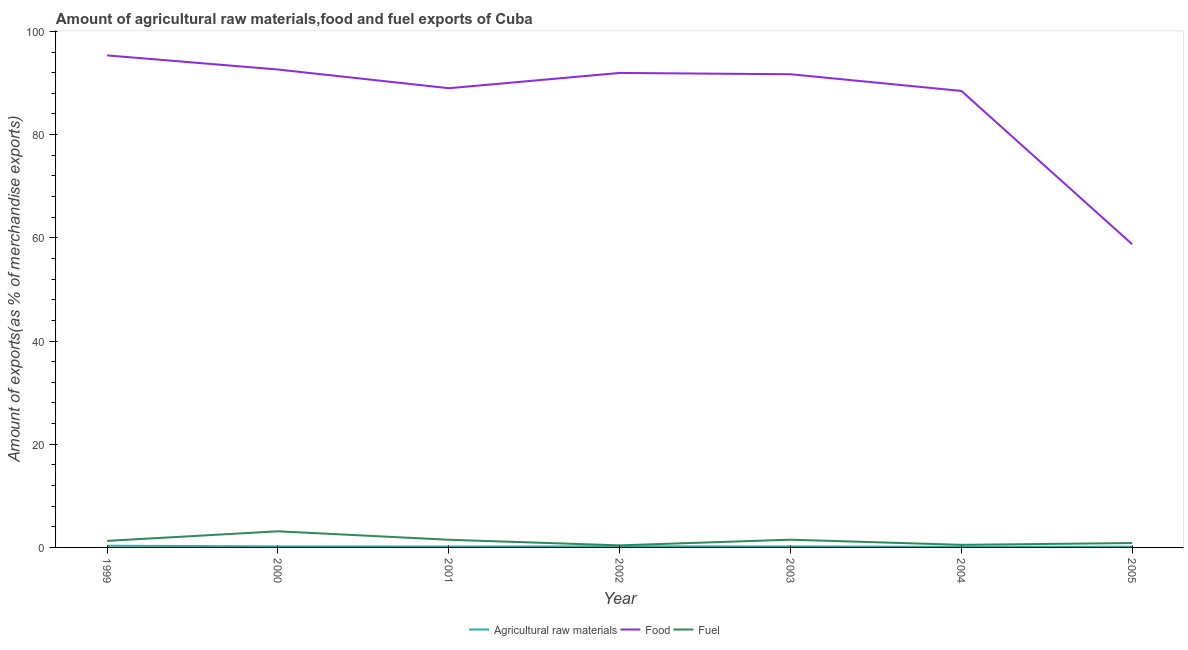How many different coloured lines are there?
Keep it short and to the point. 3. Does the line corresponding to percentage of raw materials exports intersect with the line corresponding to percentage of food exports?
Offer a very short reply. No. What is the percentage of fuel exports in 1999?
Make the answer very short. 1.27. Across all years, what is the maximum percentage of raw materials exports?
Offer a terse response. 0.32. Across all years, what is the minimum percentage of raw materials exports?
Provide a short and direct response. 0.12. In which year was the percentage of food exports maximum?
Make the answer very short. 1999. In which year was the percentage of food exports minimum?
Your response must be concise. 2005. What is the total percentage of raw materials exports in the graph?
Keep it short and to the point. 1.38. What is the difference between the percentage of raw materials exports in 2000 and that in 2001?
Your answer should be compact. 0.02. What is the difference between the percentage of fuel exports in 2001 and the percentage of food exports in 2002?
Your response must be concise. -90.47. What is the average percentage of food exports per year?
Your response must be concise. 86.83. In the year 2003, what is the difference between the percentage of raw materials exports and percentage of food exports?
Your answer should be compact. -91.51. In how many years, is the percentage of food exports greater than 88 %?
Your response must be concise. 6. What is the ratio of the percentage of food exports in 1999 to that in 2004?
Ensure brevity in your answer.  1.08. What is the difference between the highest and the second highest percentage of food exports?
Your answer should be very brief. 2.74. What is the difference between the highest and the lowest percentage of raw materials exports?
Your answer should be very brief. 0.2. In how many years, is the percentage of raw materials exports greater than the average percentage of raw materials exports taken over all years?
Your response must be concise. 3. Is it the case that in every year, the sum of the percentage of raw materials exports and percentage of food exports is greater than the percentage of fuel exports?
Offer a terse response. Yes. Does the percentage of food exports monotonically increase over the years?
Make the answer very short. No. How many lines are there?
Make the answer very short. 3. What is the difference between two consecutive major ticks on the Y-axis?
Give a very brief answer. 20. Are the values on the major ticks of Y-axis written in scientific E-notation?
Ensure brevity in your answer.  No. Does the graph contain grids?
Give a very brief answer. No. How many legend labels are there?
Your answer should be compact. 3. How are the legend labels stacked?
Your response must be concise. Horizontal. What is the title of the graph?
Provide a succinct answer. Amount of agricultural raw materials,food and fuel exports of Cuba. Does "Industry" appear as one of the legend labels in the graph?
Your response must be concise. No. What is the label or title of the Y-axis?
Give a very brief answer. Amount of exports(as % of merchandise exports). What is the Amount of exports(as % of merchandise exports) in Agricultural raw materials in 1999?
Your answer should be very brief. 0.32. What is the Amount of exports(as % of merchandise exports) of Food in 1999?
Your answer should be compact. 95.35. What is the Amount of exports(as % of merchandise exports) in Fuel in 1999?
Offer a terse response. 1.27. What is the Amount of exports(as % of merchandise exports) of Agricultural raw materials in 2000?
Your response must be concise. 0.2. What is the Amount of exports(as % of merchandise exports) of Food in 2000?
Make the answer very short. 92.62. What is the Amount of exports(as % of merchandise exports) of Fuel in 2000?
Your answer should be very brief. 3.13. What is the Amount of exports(as % of merchandise exports) of Agricultural raw materials in 2001?
Make the answer very short. 0.18. What is the Amount of exports(as % of merchandise exports) in Food in 2001?
Offer a terse response. 88.99. What is the Amount of exports(as % of merchandise exports) of Fuel in 2001?
Provide a short and direct response. 1.49. What is the Amount of exports(as % of merchandise exports) of Agricultural raw materials in 2002?
Provide a succinct answer. 0.21. What is the Amount of exports(as % of merchandise exports) in Food in 2002?
Your answer should be compact. 91.95. What is the Amount of exports(as % of merchandise exports) of Fuel in 2002?
Make the answer very short. 0.4. What is the Amount of exports(as % of merchandise exports) in Agricultural raw materials in 2003?
Offer a very short reply. 0.2. What is the Amount of exports(as % of merchandise exports) of Food in 2003?
Your answer should be very brief. 91.7. What is the Amount of exports(as % of merchandise exports) in Fuel in 2003?
Your response must be concise. 1.5. What is the Amount of exports(as % of merchandise exports) of Agricultural raw materials in 2004?
Give a very brief answer. 0.12. What is the Amount of exports(as % of merchandise exports) in Food in 2004?
Offer a very short reply. 88.46. What is the Amount of exports(as % of merchandise exports) of Fuel in 2004?
Provide a succinct answer. 0.5. What is the Amount of exports(as % of merchandise exports) of Agricultural raw materials in 2005?
Provide a short and direct response. 0.14. What is the Amount of exports(as % of merchandise exports) in Food in 2005?
Keep it short and to the point. 58.74. What is the Amount of exports(as % of merchandise exports) in Fuel in 2005?
Your answer should be very brief. 0.85. Across all years, what is the maximum Amount of exports(as % of merchandise exports) of Agricultural raw materials?
Your answer should be very brief. 0.32. Across all years, what is the maximum Amount of exports(as % of merchandise exports) of Food?
Keep it short and to the point. 95.35. Across all years, what is the maximum Amount of exports(as % of merchandise exports) of Fuel?
Your answer should be very brief. 3.13. Across all years, what is the minimum Amount of exports(as % of merchandise exports) in Agricultural raw materials?
Provide a succinct answer. 0.12. Across all years, what is the minimum Amount of exports(as % of merchandise exports) in Food?
Ensure brevity in your answer.  58.74. Across all years, what is the minimum Amount of exports(as % of merchandise exports) in Fuel?
Your answer should be compact. 0.4. What is the total Amount of exports(as % of merchandise exports) of Agricultural raw materials in the graph?
Ensure brevity in your answer.  1.38. What is the total Amount of exports(as % of merchandise exports) in Food in the graph?
Your answer should be very brief. 607.83. What is the total Amount of exports(as % of merchandise exports) of Fuel in the graph?
Your answer should be compact. 9.13. What is the difference between the Amount of exports(as % of merchandise exports) in Agricultural raw materials in 1999 and that in 2000?
Provide a short and direct response. 0.12. What is the difference between the Amount of exports(as % of merchandise exports) of Food in 1999 and that in 2000?
Your answer should be compact. 2.74. What is the difference between the Amount of exports(as % of merchandise exports) in Fuel in 1999 and that in 2000?
Offer a terse response. -1.86. What is the difference between the Amount of exports(as % of merchandise exports) in Agricultural raw materials in 1999 and that in 2001?
Your answer should be very brief. 0.15. What is the difference between the Amount of exports(as % of merchandise exports) in Food in 1999 and that in 2001?
Provide a succinct answer. 6.36. What is the difference between the Amount of exports(as % of merchandise exports) in Fuel in 1999 and that in 2001?
Offer a terse response. -0.22. What is the difference between the Amount of exports(as % of merchandise exports) of Agricultural raw materials in 1999 and that in 2002?
Offer a very short reply. 0.11. What is the difference between the Amount of exports(as % of merchandise exports) in Food in 1999 and that in 2002?
Ensure brevity in your answer.  3.4. What is the difference between the Amount of exports(as % of merchandise exports) of Fuel in 1999 and that in 2002?
Keep it short and to the point. 0.87. What is the difference between the Amount of exports(as % of merchandise exports) in Agricultural raw materials in 1999 and that in 2003?
Ensure brevity in your answer.  0.13. What is the difference between the Amount of exports(as % of merchandise exports) in Food in 1999 and that in 2003?
Make the answer very short. 3.65. What is the difference between the Amount of exports(as % of merchandise exports) of Fuel in 1999 and that in 2003?
Ensure brevity in your answer.  -0.23. What is the difference between the Amount of exports(as % of merchandise exports) in Agricultural raw materials in 1999 and that in 2004?
Your answer should be compact. 0.2. What is the difference between the Amount of exports(as % of merchandise exports) in Food in 1999 and that in 2004?
Make the answer very short. 6.89. What is the difference between the Amount of exports(as % of merchandise exports) in Fuel in 1999 and that in 2004?
Keep it short and to the point. 0.77. What is the difference between the Amount of exports(as % of merchandise exports) of Agricultural raw materials in 1999 and that in 2005?
Offer a very short reply. 0.18. What is the difference between the Amount of exports(as % of merchandise exports) in Food in 1999 and that in 2005?
Provide a succinct answer. 36.61. What is the difference between the Amount of exports(as % of merchandise exports) in Fuel in 1999 and that in 2005?
Give a very brief answer. 0.42. What is the difference between the Amount of exports(as % of merchandise exports) in Agricultural raw materials in 2000 and that in 2001?
Provide a short and direct response. 0.02. What is the difference between the Amount of exports(as % of merchandise exports) of Food in 2000 and that in 2001?
Your response must be concise. 3.62. What is the difference between the Amount of exports(as % of merchandise exports) of Fuel in 2000 and that in 2001?
Provide a succinct answer. 1.64. What is the difference between the Amount of exports(as % of merchandise exports) in Agricultural raw materials in 2000 and that in 2002?
Ensure brevity in your answer.  -0.01. What is the difference between the Amount of exports(as % of merchandise exports) in Food in 2000 and that in 2002?
Keep it short and to the point. 0.66. What is the difference between the Amount of exports(as % of merchandise exports) of Fuel in 2000 and that in 2002?
Provide a succinct answer. 2.72. What is the difference between the Amount of exports(as % of merchandise exports) in Agricultural raw materials in 2000 and that in 2003?
Your answer should be very brief. 0. What is the difference between the Amount of exports(as % of merchandise exports) of Food in 2000 and that in 2003?
Offer a terse response. 0.91. What is the difference between the Amount of exports(as % of merchandise exports) of Fuel in 2000 and that in 2003?
Your response must be concise. 1.63. What is the difference between the Amount of exports(as % of merchandise exports) in Agricultural raw materials in 2000 and that in 2004?
Provide a short and direct response. 0.08. What is the difference between the Amount of exports(as % of merchandise exports) in Food in 2000 and that in 2004?
Give a very brief answer. 4.15. What is the difference between the Amount of exports(as % of merchandise exports) in Fuel in 2000 and that in 2004?
Provide a short and direct response. 2.63. What is the difference between the Amount of exports(as % of merchandise exports) of Agricultural raw materials in 2000 and that in 2005?
Keep it short and to the point. 0.06. What is the difference between the Amount of exports(as % of merchandise exports) in Food in 2000 and that in 2005?
Offer a terse response. 33.87. What is the difference between the Amount of exports(as % of merchandise exports) in Fuel in 2000 and that in 2005?
Your response must be concise. 2.28. What is the difference between the Amount of exports(as % of merchandise exports) of Agricultural raw materials in 2001 and that in 2002?
Your answer should be compact. -0.04. What is the difference between the Amount of exports(as % of merchandise exports) in Food in 2001 and that in 2002?
Provide a succinct answer. -2.96. What is the difference between the Amount of exports(as % of merchandise exports) of Fuel in 2001 and that in 2002?
Your response must be concise. 1.08. What is the difference between the Amount of exports(as % of merchandise exports) of Agricultural raw materials in 2001 and that in 2003?
Your answer should be very brief. -0.02. What is the difference between the Amount of exports(as % of merchandise exports) of Food in 2001 and that in 2003?
Provide a short and direct response. -2.71. What is the difference between the Amount of exports(as % of merchandise exports) of Fuel in 2001 and that in 2003?
Keep it short and to the point. -0.01. What is the difference between the Amount of exports(as % of merchandise exports) in Agricultural raw materials in 2001 and that in 2004?
Your response must be concise. 0.05. What is the difference between the Amount of exports(as % of merchandise exports) in Food in 2001 and that in 2004?
Give a very brief answer. 0.53. What is the difference between the Amount of exports(as % of merchandise exports) of Fuel in 2001 and that in 2004?
Offer a very short reply. 0.99. What is the difference between the Amount of exports(as % of merchandise exports) of Agricultural raw materials in 2001 and that in 2005?
Make the answer very short. 0.03. What is the difference between the Amount of exports(as % of merchandise exports) of Food in 2001 and that in 2005?
Provide a succinct answer. 30.25. What is the difference between the Amount of exports(as % of merchandise exports) of Fuel in 2001 and that in 2005?
Provide a succinct answer. 0.64. What is the difference between the Amount of exports(as % of merchandise exports) of Agricultural raw materials in 2002 and that in 2003?
Your answer should be compact. 0.02. What is the difference between the Amount of exports(as % of merchandise exports) of Food in 2002 and that in 2003?
Give a very brief answer. 0.25. What is the difference between the Amount of exports(as % of merchandise exports) of Fuel in 2002 and that in 2003?
Provide a succinct answer. -1.1. What is the difference between the Amount of exports(as % of merchandise exports) of Agricultural raw materials in 2002 and that in 2004?
Ensure brevity in your answer.  0.09. What is the difference between the Amount of exports(as % of merchandise exports) of Food in 2002 and that in 2004?
Ensure brevity in your answer.  3.49. What is the difference between the Amount of exports(as % of merchandise exports) in Fuel in 2002 and that in 2004?
Provide a short and direct response. -0.1. What is the difference between the Amount of exports(as % of merchandise exports) in Agricultural raw materials in 2002 and that in 2005?
Make the answer very short. 0.07. What is the difference between the Amount of exports(as % of merchandise exports) in Food in 2002 and that in 2005?
Offer a terse response. 33.21. What is the difference between the Amount of exports(as % of merchandise exports) of Fuel in 2002 and that in 2005?
Keep it short and to the point. -0.45. What is the difference between the Amount of exports(as % of merchandise exports) in Agricultural raw materials in 2003 and that in 2004?
Make the answer very short. 0.07. What is the difference between the Amount of exports(as % of merchandise exports) of Food in 2003 and that in 2004?
Your answer should be compact. 3.24. What is the difference between the Amount of exports(as % of merchandise exports) of Fuel in 2003 and that in 2004?
Ensure brevity in your answer.  1. What is the difference between the Amount of exports(as % of merchandise exports) in Agricultural raw materials in 2003 and that in 2005?
Your answer should be compact. 0.05. What is the difference between the Amount of exports(as % of merchandise exports) of Food in 2003 and that in 2005?
Give a very brief answer. 32.96. What is the difference between the Amount of exports(as % of merchandise exports) of Fuel in 2003 and that in 2005?
Your response must be concise. 0.65. What is the difference between the Amount of exports(as % of merchandise exports) of Agricultural raw materials in 2004 and that in 2005?
Your answer should be very brief. -0.02. What is the difference between the Amount of exports(as % of merchandise exports) of Food in 2004 and that in 2005?
Offer a very short reply. 29.72. What is the difference between the Amount of exports(as % of merchandise exports) of Fuel in 2004 and that in 2005?
Offer a very short reply. -0.35. What is the difference between the Amount of exports(as % of merchandise exports) in Agricultural raw materials in 1999 and the Amount of exports(as % of merchandise exports) in Food in 2000?
Your answer should be compact. -92.29. What is the difference between the Amount of exports(as % of merchandise exports) in Agricultural raw materials in 1999 and the Amount of exports(as % of merchandise exports) in Fuel in 2000?
Give a very brief answer. -2.8. What is the difference between the Amount of exports(as % of merchandise exports) of Food in 1999 and the Amount of exports(as % of merchandise exports) of Fuel in 2000?
Your answer should be compact. 92.23. What is the difference between the Amount of exports(as % of merchandise exports) of Agricultural raw materials in 1999 and the Amount of exports(as % of merchandise exports) of Food in 2001?
Ensure brevity in your answer.  -88.67. What is the difference between the Amount of exports(as % of merchandise exports) in Agricultural raw materials in 1999 and the Amount of exports(as % of merchandise exports) in Fuel in 2001?
Offer a very short reply. -1.16. What is the difference between the Amount of exports(as % of merchandise exports) of Food in 1999 and the Amount of exports(as % of merchandise exports) of Fuel in 2001?
Offer a terse response. 93.87. What is the difference between the Amount of exports(as % of merchandise exports) in Agricultural raw materials in 1999 and the Amount of exports(as % of merchandise exports) in Food in 2002?
Offer a very short reply. -91.63. What is the difference between the Amount of exports(as % of merchandise exports) of Agricultural raw materials in 1999 and the Amount of exports(as % of merchandise exports) of Fuel in 2002?
Ensure brevity in your answer.  -0.08. What is the difference between the Amount of exports(as % of merchandise exports) of Food in 1999 and the Amount of exports(as % of merchandise exports) of Fuel in 2002?
Ensure brevity in your answer.  94.95. What is the difference between the Amount of exports(as % of merchandise exports) of Agricultural raw materials in 1999 and the Amount of exports(as % of merchandise exports) of Food in 2003?
Offer a very short reply. -91.38. What is the difference between the Amount of exports(as % of merchandise exports) of Agricultural raw materials in 1999 and the Amount of exports(as % of merchandise exports) of Fuel in 2003?
Make the answer very short. -1.18. What is the difference between the Amount of exports(as % of merchandise exports) of Food in 1999 and the Amount of exports(as % of merchandise exports) of Fuel in 2003?
Give a very brief answer. 93.85. What is the difference between the Amount of exports(as % of merchandise exports) of Agricultural raw materials in 1999 and the Amount of exports(as % of merchandise exports) of Food in 2004?
Your answer should be very brief. -88.14. What is the difference between the Amount of exports(as % of merchandise exports) of Agricultural raw materials in 1999 and the Amount of exports(as % of merchandise exports) of Fuel in 2004?
Your response must be concise. -0.18. What is the difference between the Amount of exports(as % of merchandise exports) in Food in 1999 and the Amount of exports(as % of merchandise exports) in Fuel in 2004?
Offer a very short reply. 94.85. What is the difference between the Amount of exports(as % of merchandise exports) of Agricultural raw materials in 1999 and the Amount of exports(as % of merchandise exports) of Food in 2005?
Your answer should be very brief. -58.42. What is the difference between the Amount of exports(as % of merchandise exports) in Agricultural raw materials in 1999 and the Amount of exports(as % of merchandise exports) in Fuel in 2005?
Provide a short and direct response. -0.53. What is the difference between the Amount of exports(as % of merchandise exports) of Food in 1999 and the Amount of exports(as % of merchandise exports) of Fuel in 2005?
Offer a very short reply. 94.5. What is the difference between the Amount of exports(as % of merchandise exports) in Agricultural raw materials in 2000 and the Amount of exports(as % of merchandise exports) in Food in 2001?
Ensure brevity in your answer.  -88.79. What is the difference between the Amount of exports(as % of merchandise exports) in Agricultural raw materials in 2000 and the Amount of exports(as % of merchandise exports) in Fuel in 2001?
Ensure brevity in your answer.  -1.29. What is the difference between the Amount of exports(as % of merchandise exports) in Food in 2000 and the Amount of exports(as % of merchandise exports) in Fuel in 2001?
Provide a short and direct response. 91.13. What is the difference between the Amount of exports(as % of merchandise exports) of Agricultural raw materials in 2000 and the Amount of exports(as % of merchandise exports) of Food in 2002?
Give a very brief answer. -91.75. What is the difference between the Amount of exports(as % of merchandise exports) in Agricultural raw materials in 2000 and the Amount of exports(as % of merchandise exports) in Fuel in 2002?
Your answer should be very brief. -0.2. What is the difference between the Amount of exports(as % of merchandise exports) of Food in 2000 and the Amount of exports(as % of merchandise exports) of Fuel in 2002?
Give a very brief answer. 92.21. What is the difference between the Amount of exports(as % of merchandise exports) in Agricultural raw materials in 2000 and the Amount of exports(as % of merchandise exports) in Food in 2003?
Give a very brief answer. -91.5. What is the difference between the Amount of exports(as % of merchandise exports) in Agricultural raw materials in 2000 and the Amount of exports(as % of merchandise exports) in Fuel in 2003?
Offer a terse response. -1.3. What is the difference between the Amount of exports(as % of merchandise exports) of Food in 2000 and the Amount of exports(as % of merchandise exports) of Fuel in 2003?
Offer a very short reply. 91.12. What is the difference between the Amount of exports(as % of merchandise exports) in Agricultural raw materials in 2000 and the Amount of exports(as % of merchandise exports) in Food in 2004?
Keep it short and to the point. -88.26. What is the difference between the Amount of exports(as % of merchandise exports) of Agricultural raw materials in 2000 and the Amount of exports(as % of merchandise exports) of Fuel in 2004?
Your answer should be compact. -0.3. What is the difference between the Amount of exports(as % of merchandise exports) in Food in 2000 and the Amount of exports(as % of merchandise exports) in Fuel in 2004?
Keep it short and to the point. 92.12. What is the difference between the Amount of exports(as % of merchandise exports) of Agricultural raw materials in 2000 and the Amount of exports(as % of merchandise exports) of Food in 2005?
Provide a succinct answer. -58.54. What is the difference between the Amount of exports(as % of merchandise exports) in Agricultural raw materials in 2000 and the Amount of exports(as % of merchandise exports) in Fuel in 2005?
Keep it short and to the point. -0.65. What is the difference between the Amount of exports(as % of merchandise exports) in Food in 2000 and the Amount of exports(as % of merchandise exports) in Fuel in 2005?
Give a very brief answer. 91.77. What is the difference between the Amount of exports(as % of merchandise exports) in Agricultural raw materials in 2001 and the Amount of exports(as % of merchandise exports) in Food in 2002?
Provide a short and direct response. -91.78. What is the difference between the Amount of exports(as % of merchandise exports) in Agricultural raw materials in 2001 and the Amount of exports(as % of merchandise exports) in Fuel in 2002?
Make the answer very short. -0.23. What is the difference between the Amount of exports(as % of merchandise exports) of Food in 2001 and the Amount of exports(as % of merchandise exports) of Fuel in 2002?
Give a very brief answer. 88.59. What is the difference between the Amount of exports(as % of merchandise exports) in Agricultural raw materials in 2001 and the Amount of exports(as % of merchandise exports) in Food in 2003?
Your response must be concise. -91.53. What is the difference between the Amount of exports(as % of merchandise exports) in Agricultural raw materials in 2001 and the Amount of exports(as % of merchandise exports) in Fuel in 2003?
Ensure brevity in your answer.  -1.32. What is the difference between the Amount of exports(as % of merchandise exports) of Food in 2001 and the Amount of exports(as % of merchandise exports) of Fuel in 2003?
Your answer should be very brief. 87.49. What is the difference between the Amount of exports(as % of merchandise exports) of Agricultural raw materials in 2001 and the Amount of exports(as % of merchandise exports) of Food in 2004?
Your answer should be very brief. -88.29. What is the difference between the Amount of exports(as % of merchandise exports) in Agricultural raw materials in 2001 and the Amount of exports(as % of merchandise exports) in Fuel in 2004?
Make the answer very short. -0.32. What is the difference between the Amount of exports(as % of merchandise exports) of Food in 2001 and the Amount of exports(as % of merchandise exports) of Fuel in 2004?
Provide a succinct answer. 88.49. What is the difference between the Amount of exports(as % of merchandise exports) of Agricultural raw materials in 2001 and the Amount of exports(as % of merchandise exports) of Food in 2005?
Your answer should be very brief. -58.57. What is the difference between the Amount of exports(as % of merchandise exports) of Agricultural raw materials in 2001 and the Amount of exports(as % of merchandise exports) of Fuel in 2005?
Ensure brevity in your answer.  -0.67. What is the difference between the Amount of exports(as % of merchandise exports) of Food in 2001 and the Amount of exports(as % of merchandise exports) of Fuel in 2005?
Offer a very short reply. 88.14. What is the difference between the Amount of exports(as % of merchandise exports) of Agricultural raw materials in 2002 and the Amount of exports(as % of merchandise exports) of Food in 2003?
Ensure brevity in your answer.  -91.49. What is the difference between the Amount of exports(as % of merchandise exports) in Agricultural raw materials in 2002 and the Amount of exports(as % of merchandise exports) in Fuel in 2003?
Give a very brief answer. -1.29. What is the difference between the Amount of exports(as % of merchandise exports) of Food in 2002 and the Amount of exports(as % of merchandise exports) of Fuel in 2003?
Your answer should be compact. 90.45. What is the difference between the Amount of exports(as % of merchandise exports) of Agricultural raw materials in 2002 and the Amount of exports(as % of merchandise exports) of Food in 2004?
Give a very brief answer. -88.25. What is the difference between the Amount of exports(as % of merchandise exports) in Agricultural raw materials in 2002 and the Amount of exports(as % of merchandise exports) in Fuel in 2004?
Your answer should be compact. -0.29. What is the difference between the Amount of exports(as % of merchandise exports) of Food in 2002 and the Amount of exports(as % of merchandise exports) of Fuel in 2004?
Make the answer very short. 91.45. What is the difference between the Amount of exports(as % of merchandise exports) of Agricultural raw materials in 2002 and the Amount of exports(as % of merchandise exports) of Food in 2005?
Make the answer very short. -58.53. What is the difference between the Amount of exports(as % of merchandise exports) of Agricultural raw materials in 2002 and the Amount of exports(as % of merchandise exports) of Fuel in 2005?
Provide a short and direct response. -0.64. What is the difference between the Amount of exports(as % of merchandise exports) in Food in 2002 and the Amount of exports(as % of merchandise exports) in Fuel in 2005?
Your response must be concise. 91.1. What is the difference between the Amount of exports(as % of merchandise exports) in Agricultural raw materials in 2003 and the Amount of exports(as % of merchandise exports) in Food in 2004?
Your response must be concise. -88.27. What is the difference between the Amount of exports(as % of merchandise exports) of Agricultural raw materials in 2003 and the Amount of exports(as % of merchandise exports) of Fuel in 2004?
Offer a very short reply. -0.3. What is the difference between the Amount of exports(as % of merchandise exports) of Food in 2003 and the Amount of exports(as % of merchandise exports) of Fuel in 2004?
Offer a very short reply. 91.2. What is the difference between the Amount of exports(as % of merchandise exports) of Agricultural raw materials in 2003 and the Amount of exports(as % of merchandise exports) of Food in 2005?
Keep it short and to the point. -58.55. What is the difference between the Amount of exports(as % of merchandise exports) in Agricultural raw materials in 2003 and the Amount of exports(as % of merchandise exports) in Fuel in 2005?
Give a very brief answer. -0.65. What is the difference between the Amount of exports(as % of merchandise exports) of Food in 2003 and the Amount of exports(as % of merchandise exports) of Fuel in 2005?
Offer a terse response. 90.85. What is the difference between the Amount of exports(as % of merchandise exports) of Agricultural raw materials in 2004 and the Amount of exports(as % of merchandise exports) of Food in 2005?
Keep it short and to the point. -58.62. What is the difference between the Amount of exports(as % of merchandise exports) of Agricultural raw materials in 2004 and the Amount of exports(as % of merchandise exports) of Fuel in 2005?
Offer a terse response. -0.73. What is the difference between the Amount of exports(as % of merchandise exports) in Food in 2004 and the Amount of exports(as % of merchandise exports) in Fuel in 2005?
Keep it short and to the point. 87.62. What is the average Amount of exports(as % of merchandise exports) of Agricultural raw materials per year?
Offer a very short reply. 0.2. What is the average Amount of exports(as % of merchandise exports) of Food per year?
Your answer should be compact. 86.83. What is the average Amount of exports(as % of merchandise exports) in Fuel per year?
Offer a very short reply. 1.3. In the year 1999, what is the difference between the Amount of exports(as % of merchandise exports) of Agricultural raw materials and Amount of exports(as % of merchandise exports) of Food?
Your response must be concise. -95.03. In the year 1999, what is the difference between the Amount of exports(as % of merchandise exports) in Agricultural raw materials and Amount of exports(as % of merchandise exports) in Fuel?
Your answer should be compact. -0.94. In the year 1999, what is the difference between the Amount of exports(as % of merchandise exports) in Food and Amount of exports(as % of merchandise exports) in Fuel?
Make the answer very short. 94.08. In the year 2000, what is the difference between the Amount of exports(as % of merchandise exports) of Agricultural raw materials and Amount of exports(as % of merchandise exports) of Food?
Your response must be concise. -92.42. In the year 2000, what is the difference between the Amount of exports(as % of merchandise exports) in Agricultural raw materials and Amount of exports(as % of merchandise exports) in Fuel?
Provide a short and direct response. -2.93. In the year 2000, what is the difference between the Amount of exports(as % of merchandise exports) of Food and Amount of exports(as % of merchandise exports) of Fuel?
Provide a short and direct response. 89.49. In the year 2001, what is the difference between the Amount of exports(as % of merchandise exports) of Agricultural raw materials and Amount of exports(as % of merchandise exports) of Food?
Give a very brief answer. -88.82. In the year 2001, what is the difference between the Amount of exports(as % of merchandise exports) in Agricultural raw materials and Amount of exports(as % of merchandise exports) in Fuel?
Provide a short and direct response. -1.31. In the year 2001, what is the difference between the Amount of exports(as % of merchandise exports) of Food and Amount of exports(as % of merchandise exports) of Fuel?
Give a very brief answer. 87.51. In the year 2002, what is the difference between the Amount of exports(as % of merchandise exports) of Agricultural raw materials and Amount of exports(as % of merchandise exports) of Food?
Make the answer very short. -91.74. In the year 2002, what is the difference between the Amount of exports(as % of merchandise exports) of Agricultural raw materials and Amount of exports(as % of merchandise exports) of Fuel?
Provide a short and direct response. -0.19. In the year 2002, what is the difference between the Amount of exports(as % of merchandise exports) of Food and Amount of exports(as % of merchandise exports) of Fuel?
Your response must be concise. 91.55. In the year 2003, what is the difference between the Amount of exports(as % of merchandise exports) in Agricultural raw materials and Amount of exports(as % of merchandise exports) in Food?
Offer a very short reply. -91.51. In the year 2003, what is the difference between the Amount of exports(as % of merchandise exports) in Agricultural raw materials and Amount of exports(as % of merchandise exports) in Fuel?
Your answer should be compact. -1.3. In the year 2003, what is the difference between the Amount of exports(as % of merchandise exports) in Food and Amount of exports(as % of merchandise exports) in Fuel?
Ensure brevity in your answer.  90.2. In the year 2004, what is the difference between the Amount of exports(as % of merchandise exports) in Agricultural raw materials and Amount of exports(as % of merchandise exports) in Food?
Ensure brevity in your answer.  -88.34. In the year 2004, what is the difference between the Amount of exports(as % of merchandise exports) of Agricultural raw materials and Amount of exports(as % of merchandise exports) of Fuel?
Your answer should be compact. -0.38. In the year 2004, what is the difference between the Amount of exports(as % of merchandise exports) of Food and Amount of exports(as % of merchandise exports) of Fuel?
Offer a very short reply. 87.96. In the year 2005, what is the difference between the Amount of exports(as % of merchandise exports) in Agricultural raw materials and Amount of exports(as % of merchandise exports) in Food?
Your response must be concise. -58.6. In the year 2005, what is the difference between the Amount of exports(as % of merchandise exports) in Agricultural raw materials and Amount of exports(as % of merchandise exports) in Fuel?
Your answer should be compact. -0.71. In the year 2005, what is the difference between the Amount of exports(as % of merchandise exports) in Food and Amount of exports(as % of merchandise exports) in Fuel?
Your response must be concise. 57.89. What is the ratio of the Amount of exports(as % of merchandise exports) in Agricultural raw materials in 1999 to that in 2000?
Make the answer very short. 1.62. What is the ratio of the Amount of exports(as % of merchandise exports) of Food in 1999 to that in 2000?
Offer a very short reply. 1.03. What is the ratio of the Amount of exports(as % of merchandise exports) of Fuel in 1999 to that in 2000?
Your response must be concise. 0.41. What is the ratio of the Amount of exports(as % of merchandise exports) of Agricultural raw materials in 1999 to that in 2001?
Keep it short and to the point. 1.84. What is the ratio of the Amount of exports(as % of merchandise exports) of Food in 1999 to that in 2001?
Your answer should be very brief. 1.07. What is the ratio of the Amount of exports(as % of merchandise exports) in Fuel in 1999 to that in 2001?
Your response must be concise. 0.85. What is the ratio of the Amount of exports(as % of merchandise exports) of Agricultural raw materials in 1999 to that in 2002?
Keep it short and to the point. 1.53. What is the ratio of the Amount of exports(as % of merchandise exports) of Food in 1999 to that in 2002?
Give a very brief answer. 1.04. What is the ratio of the Amount of exports(as % of merchandise exports) of Fuel in 1999 to that in 2002?
Provide a short and direct response. 3.16. What is the ratio of the Amount of exports(as % of merchandise exports) of Agricultural raw materials in 1999 to that in 2003?
Offer a terse response. 1.65. What is the ratio of the Amount of exports(as % of merchandise exports) of Food in 1999 to that in 2003?
Your answer should be very brief. 1.04. What is the ratio of the Amount of exports(as % of merchandise exports) of Fuel in 1999 to that in 2003?
Your answer should be very brief. 0.85. What is the ratio of the Amount of exports(as % of merchandise exports) of Agricultural raw materials in 1999 to that in 2004?
Your response must be concise. 2.65. What is the ratio of the Amount of exports(as % of merchandise exports) of Food in 1999 to that in 2004?
Your answer should be very brief. 1.08. What is the ratio of the Amount of exports(as % of merchandise exports) in Fuel in 1999 to that in 2004?
Make the answer very short. 2.54. What is the ratio of the Amount of exports(as % of merchandise exports) of Agricultural raw materials in 1999 to that in 2005?
Offer a terse response. 2.25. What is the ratio of the Amount of exports(as % of merchandise exports) in Food in 1999 to that in 2005?
Offer a terse response. 1.62. What is the ratio of the Amount of exports(as % of merchandise exports) of Fuel in 1999 to that in 2005?
Your response must be concise. 1.49. What is the ratio of the Amount of exports(as % of merchandise exports) in Agricultural raw materials in 2000 to that in 2001?
Ensure brevity in your answer.  1.14. What is the ratio of the Amount of exports(as % of merchandise exports) of Food in 2000 to that in 2001?
Ensure brevity in your answer.  1.04. What is the ratio of the Amount of exports(as % of merchandise exports) of Fuel in 2000 to that in 2001?
Your answer should be compact. 2.1. What is the ratio of the Amount of exports(as % of merchandise exports) in Agricultural raw materials in 2000 to that in 2002?
Ensure brevity in your answer.  0.94. What is the ratio of the Amount of exports(as % of merchandise exports) in Food in 2000 to that in 2002?
Offer a terse response. 1.01. What is the ratio of the Amount of exports(as % of merchandise exports) of Fuel in 2000 to that in 2002?
Your response must be concise. 7.78. What is the ratio of the Amount of exports(as % of merchandise exports) of Agricultural raw materials in 2000 to that in 2003?
Offer a very short reply. 1.02. What is the ratio of the Amount of exports(as % of merchandise exports) of Fuel in 2000 to that in 2003?
Your answer should be very brief. 2.08. What is the ratio of the Amount of exports(as % of merchandise exports) in Agricultural raw materials in 2000 to that in 2004?
Offer a terse response. 1.64. What is the ratio of the Amount of exports(as % of merchandise exports) of Food in 2000 to that in 2004?
Your answer should be compact. 1.05. What is the ratio of the Amount of exports(as % of merchandise exports) of Fuel in 2000 to that in 2004?
Provide a succinct answer. 6.25. What is the ratio of the Amount of exports(as % of merchandise exports) of Agricultural raw materials in 2000 to that in 2005?
Your response must be concise. 1.39. What is the ratio of the Amount of exports(as % of merchandise exports) of Food in 2000 to that in 2005?
Keep it short and to the point. 1.58. What is the ratio of the Amount of exports(as % of merchandise exports) in Fuel in 2000 to that in 2005?
Provide a short and direct response. 3.68. What is the ratio of the Amount of exports(as % of merchandise exports) in Agricultural raw materials in 2001 to that in 2002?
Make the answer very short. 0.83. What is the ratio of the Amount of exports(as % of merchandise exports) of Food in 2001 to that in 2002?
Make the answer very short. 0.97. What is the ratio of the Amount of exports(as % of merchandise exports) in Fuel in 2001 to that in 2002?
Offer a very short reply. 3.7. What is the ratio of the Amount of exports(as % of merchandise exports) in Agricultural raw materials in 2001 to that in 2003?
Give a very brief answer. 0.9. What is the ratio of the Amount of exports(as % of merchandise exports) in Food in 2001 to that in 2003?
Give a very brief answer. 0.97. What is the ratio of the Amount of exports(as % of merchandise exports) of Agricultural raw materials in 2001 to that in 2004?
Provide a short and direct response. 1.44. What is the ratio of the Amount of exports(as % of merchandise exports) in Fuel in 2001 to that in 2004?
Offer a terse response. 2.97. What is the ratio of the Amount of exports(as % of merchandise exports) in Agricultural raw materials in 2001 to that in 2005?
Give a very brief answer. 1.23. What is the ratio of the Amount of exports(as % of merchandise exports) of Food in 2001 to that in 2005?
Ensure brevity in your answer.  1.51. What is the ratio of the Amount of exports(as % of merchandise exports) of Fuel in 2001 to that in 2005?
Make the answer very short. 1.75. What is the ratio of the Amount of exports(as % of merchandise exports) of Agricultural raw materials in 2002 to that in 2003?
Make the answer very short. 1.08. What is the ratio of the Amount of exports(as % of merchandise exports) of Fuel in 2002 to that in 2003?
Your answer should be very brief. 0.27. What is the ratio of the Amount of exports(as % of merchandise exports) of Agricultural raw materials in 2002 to that in 2004?
Keep it short and to the point. 1.73. What is the ratio of the Amount of exports(as % of merchandise exports) of Food in 2002 to that in 2004?
Your answer should be very brief. 1.04. What is the ratio of the Amount of exports(as % of merchandise exports) of Fuel in 2002 to that in 2004?
Keep it short and to the point. 0.8. What is the ratio of the Amount of exports(as % of merchandise exports) in Agricultural raw materials in 2002 to that in 2005?
Give a very brief answer. 1.48. What is the ratio of the Amount of exports(as % of merchandise exports) in Food in 2002 to that in 2005?
Ensure brevity in your answer.  1.57. What is the ratio of the Amount of exports(as % of merchandise exports) of Fuel in 2002 to that in 2005?
Your answer should be compact. 0.47. What is the ratio of the Amount of exports(as % of merchandise exports) in Agricultural raw materials in 2003 to that in 2004?
Make the answer very short. 1.6. What is the ratio of the Amount of exports(as % of merchandise exports) of Food in 2003 to that in 2004?
Make the answer very short. 1.04. What is the ratio of the Amount of exports(as % of merchandise exports) of Fuel in 2003 to that in 2004?
Offer a very short reply. 3. What is the ratio of the Amount of exports(as % of merchandise exports) in Agricultural raw materials in 2003 to that in 2005?
Offer a terse response. 1.37. What is the ratio of the Amount of exports(as % of merchandise exports) of Food in 2003 to that in 2005?
Your response must be concise. 1.56. What is the ratio of the Amount of exports(as % of merchandise exports) in Fuel in 2003 to that in 2005?
Offer a terse response. 1.77. What is the ratio of the Amount of exports(as % of merchandise exports) in Agricultural raw materials in 2004 to that in 2005?
Your response must be concise. 0.85. What is the ratio of the Amount of exports(as % of merchandise exports) of Food in 2004 to that in 2005?
Keep it short and to the point. 1.51. What is the ratio of the Amount of exports(as % of merchandise exports) in Fuel in 2004 to that in 2005?
Ensure brevity in your answer.  0.59. What is the difference between the highest and the second highest Amount of exports(as % of merchandise exports) in Agricultural raw materials?
Provide a short and direct response. 0.11. What is the difference between the highest and the second highest Amount of exports(as % of merchandise exports) of Food?
Provide a succinct answer. 2.74. What is the difference between the highest and the second highest Amount of exports(as % of merchandise exports) of Fuel?
Keep it short and to the point. 1.63. What is the difference between the highest and the lowest Amount of exports(as % of merchandise exports) in Agricultural raw materials?
Provide a succinct answer. 0.2. What is the difference between the highest and the lowest Amount of exports(as % of merchandise exports) of Food?
Your answer should be very brief. 36.61. What is the difference between the highest and the lowest Amount of exports(as % of merchandise exports) of Fuel?
Make the answer very short. 2.72. 